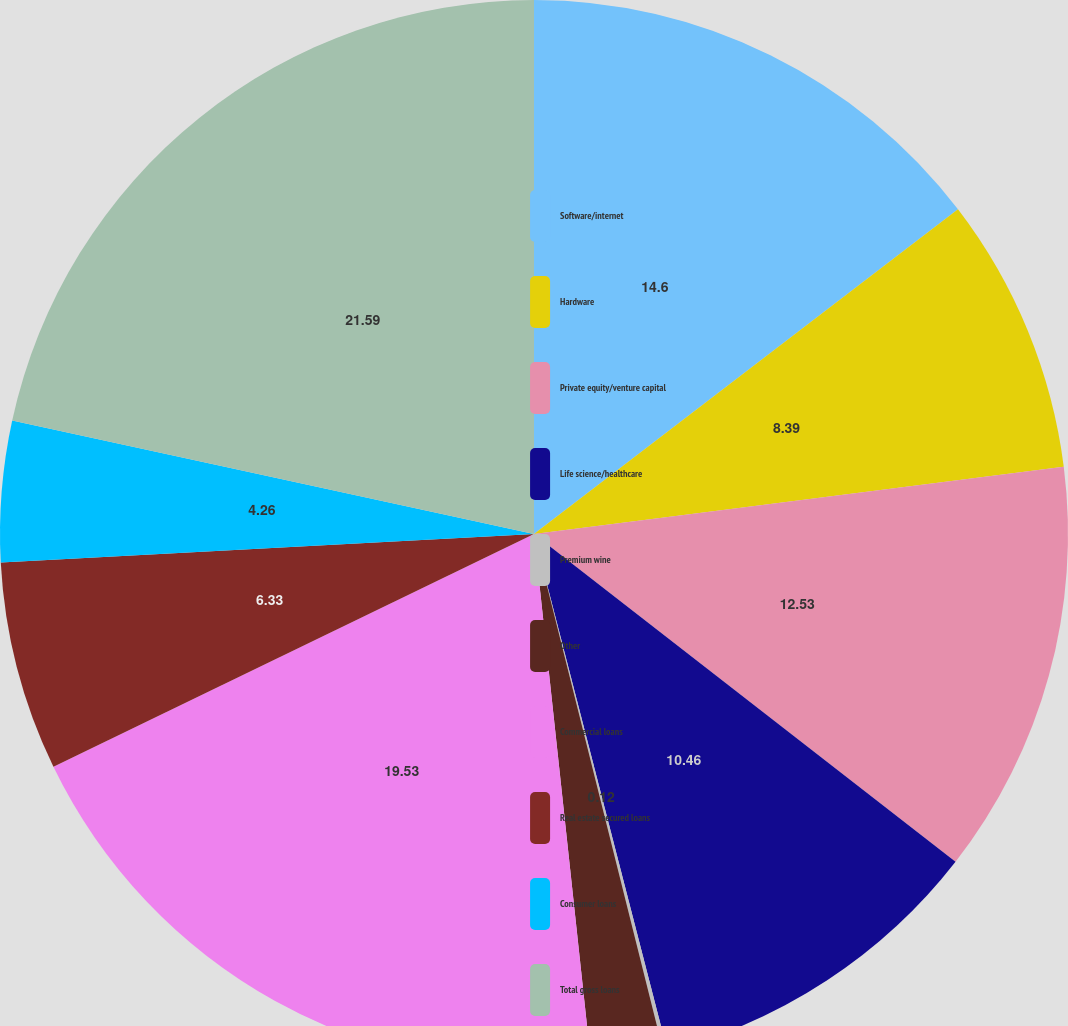<chart> <loc_0><loc_0><loc_500><loc_500><pie_chart><fcel>Software/internet<fcel>Hardware<fcel>Private equity/venture capital<fcel>Life science/healthcare<fcel>Premium wine<fcel>Other<fcel>Commercial loans<fcel>Real estate secured loans<fcel>Consumer loans<fcel>Total gross loans<nl><fcel>14.6%<fcel>8.39%<fcel>12.53%<fcel>10.46%<fcel>0.12%<fcel>2.19%<fcel>19.53%<fcel>6.33%<fcel>4.26%<fcel>21.59%<nl></chart> 